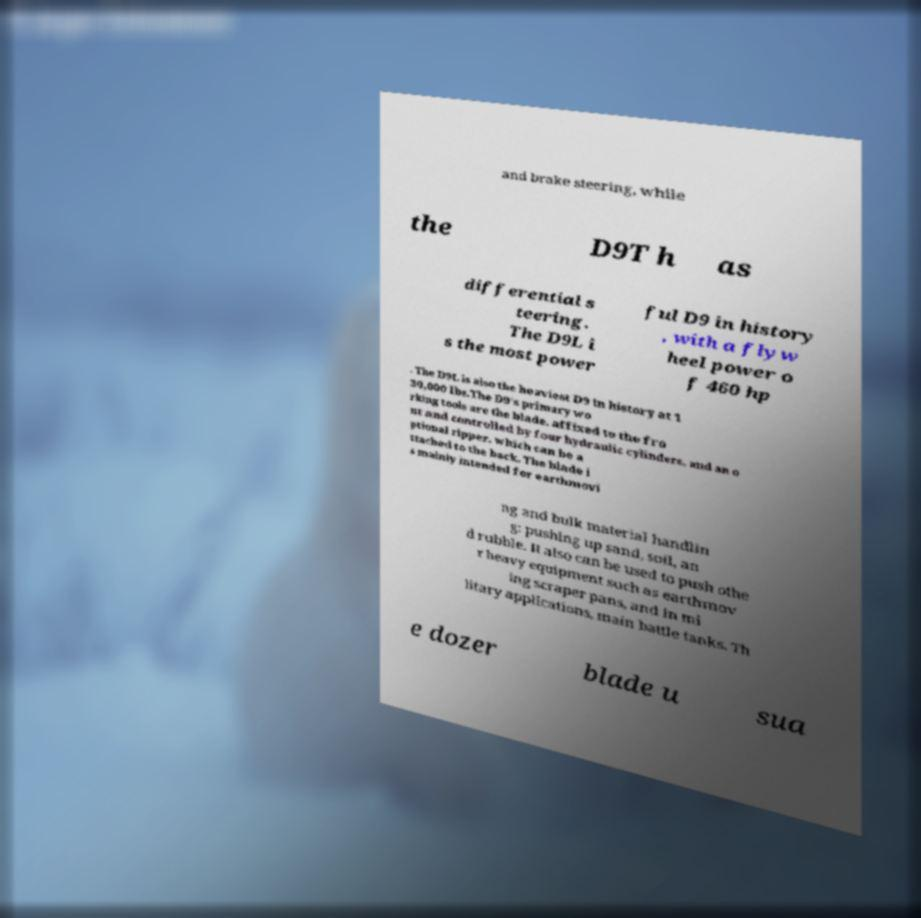There's text embedded in this image that I need extracted. Can you transcribe it verbatim? and brake steering, while the D9T h as differential s teering. The D9L i s the most power ful D9 in history , with a flyw heel power o f 460 hp . The D9L is also the heaviest D9 in history at 1 30,000 lbs.The D9's primary wo rking tools are the blade, affixed to the fro nt and controlled by four hydraulic cylinders, and an o ptional ripper, which can be a ttached to the back. The blade i s mainly intended for earthmovi ng and bulk material handlin g: pushing up sand, soil, an d rubble. It also can be used to push othe r heavy equipment such as earthmov ing scraper pans, and in mi litary applications, main battle tanks. Th e dozer blade u sua 